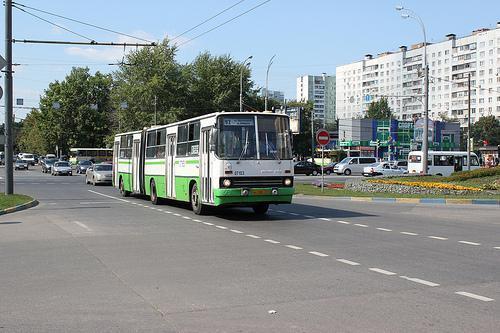How many buses are in the photo?
Give a very brief answer. 1. 